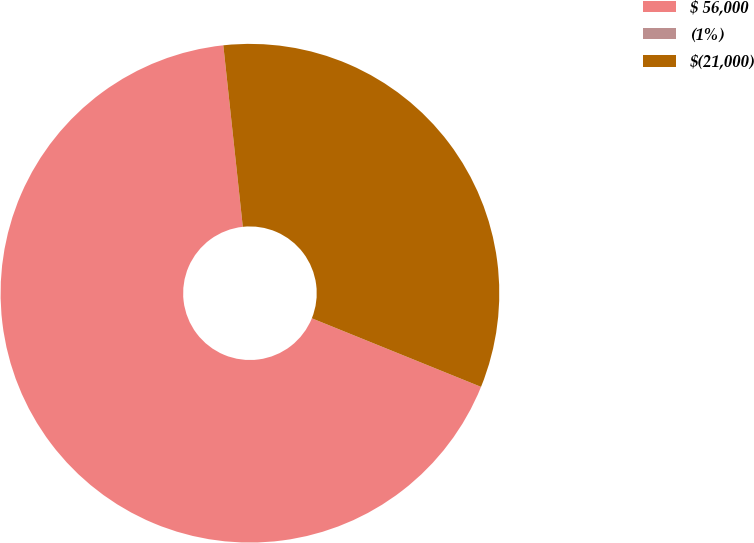Convert chart. <chart><loc_0><loc_0><loc_500><loc_500><pie_chart><fcel>$ 56,000<fcel>(1%)<fcel>$(21,000)<nl><fcel>67.17%<fcel>0.0%<fcel>32.83%<nl></chart> 